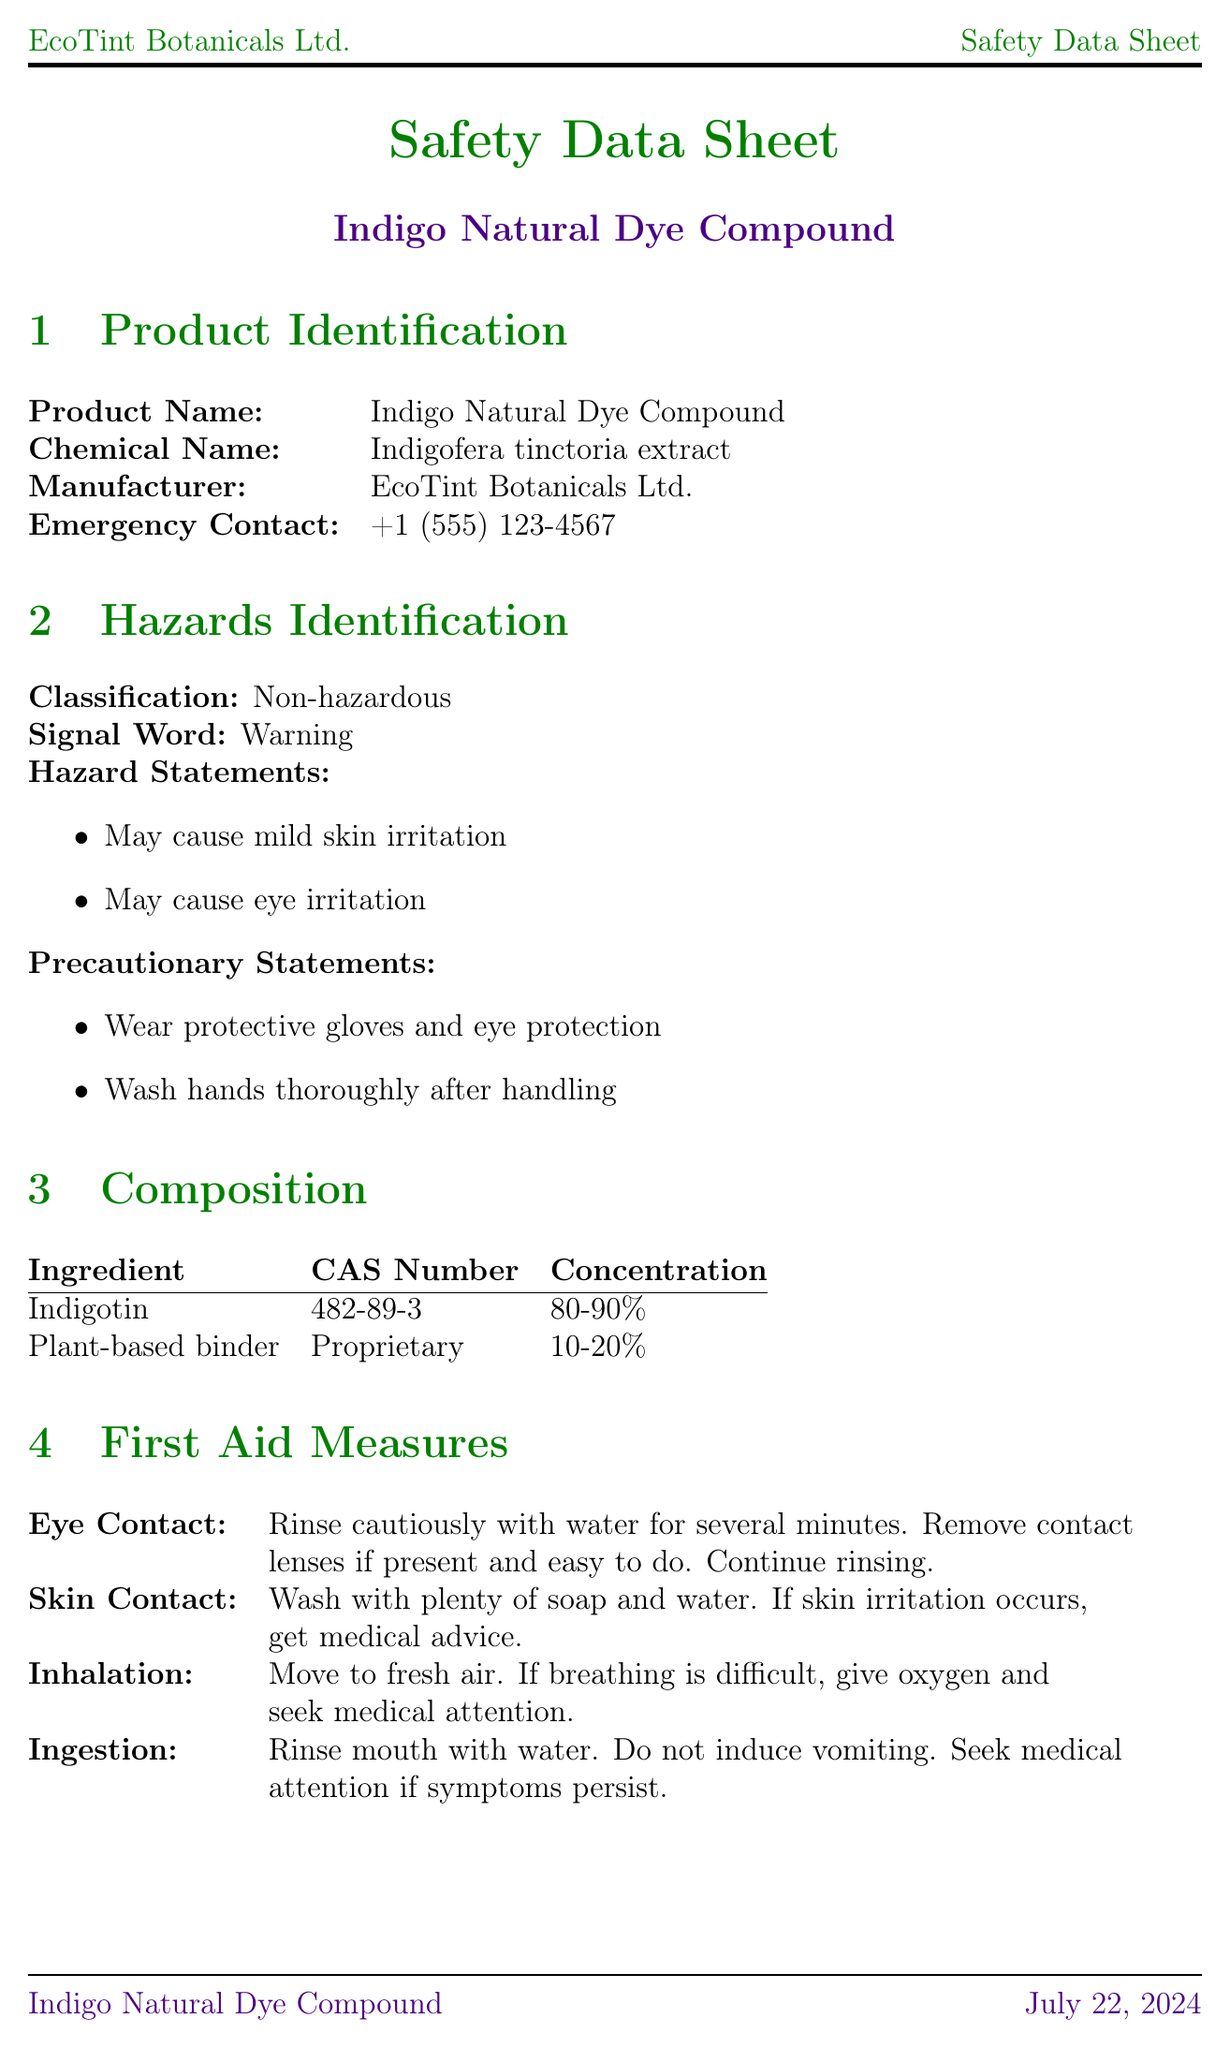What is the product name? The product name is found in the Product Identification section.
Answer: Indigo Natural Dye Compound What is the concentration range of Indigotin? The concentration range is listed under the Composition section.
Answer: 80-90% What should be worn for personal protection? The precautions for handling the compound include necessary personal protective equipment mentioned in the Exposure Controls section.
Answer: Protective gloves and eye protection What is the pH of the dye compound? The pH value is included in the Physical and Chemical Properties section.
Answer: 6.5 - 7.5 What is the recommended storage temperature? The recommended storage temperature is stated in the Handling and Storage section.
Answer: 15-25°C (59-77°F) What is the emergency contact number? The emergency contact number is in the Product Identification section for immediate assistance.
Answer: +1 (555) 123-4567 What does the product’s classification state? The classification is specified under the Hazards Identification section.
Answer: Non-hazardous What is the acute toxicity level for rats? The LD50 information is found in the Toxicological Information section regarding acute toxicity.
Answer: > 5000 mg/kg What should be done in case of skin contact? The response for skin contact is detailed in the First Aid Measures section.
Answer: Wash with plenty of soap and water 